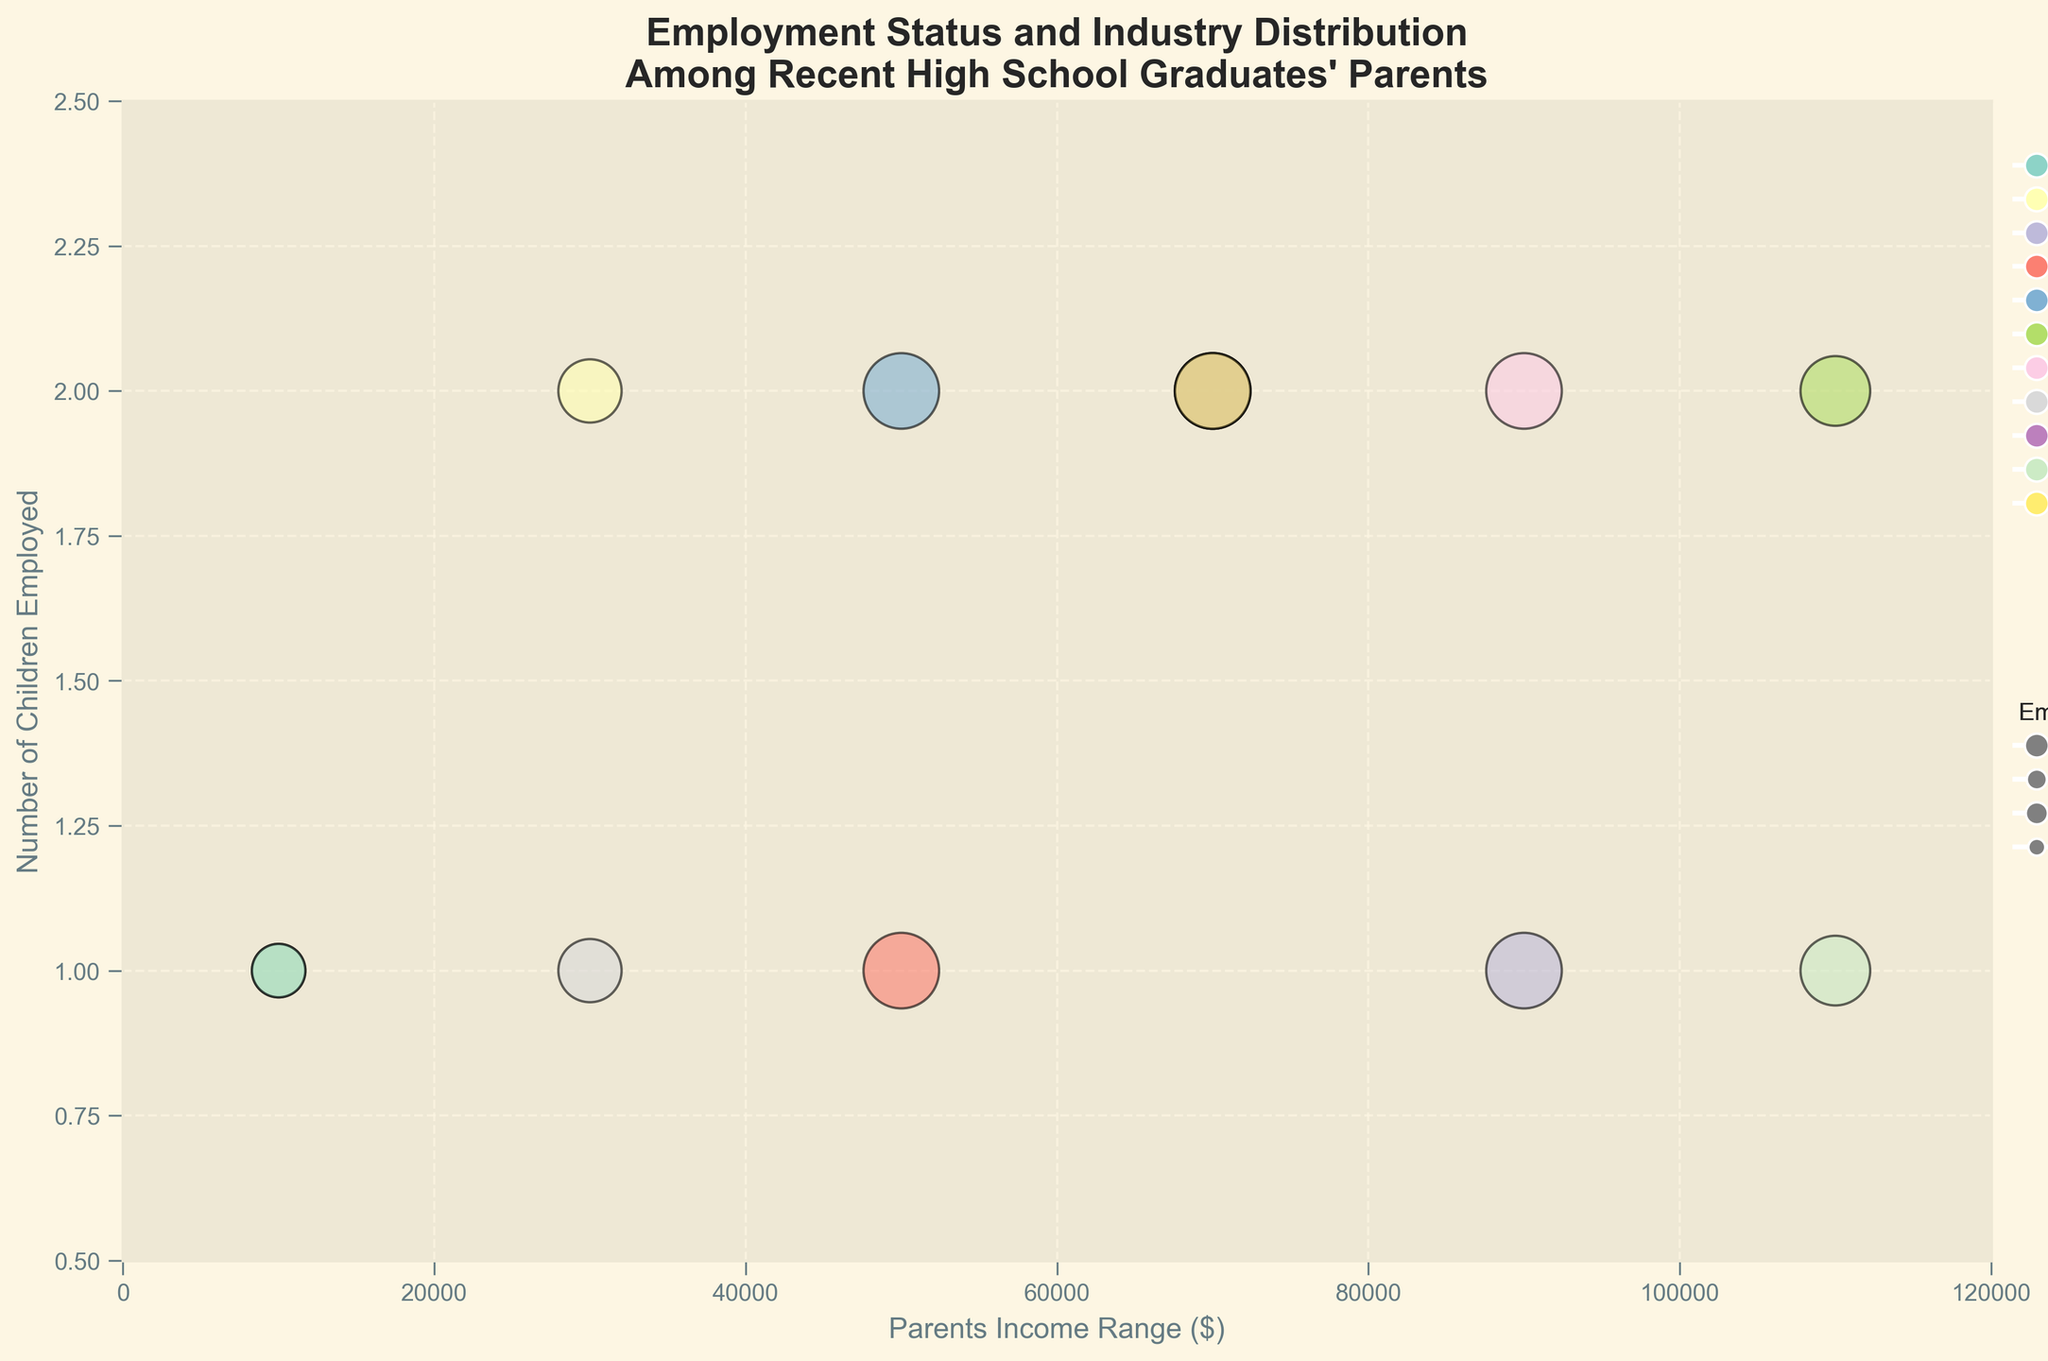What is the title of the figure? The title is usually placed at the top of the figure in a larger and bold font. In this case, it is written at the top and easy to read.
Answer: Employment Status and Industry Distribution Among Recent High School Graduates' Parents What is the range of the x-axis? The x-axis represents the Parents Income Range and spans from the minimum to the maximum value mentioned. Here, it is shown from 0 to 120000.
Answer: 0 to 120000 How many parents are from the Technology industry? Each bubble color represents a different industry. There is only one bubble colored accordingly representing Technology in the figure.
Answer: 1 Which employment status category has the largest bubbles? Employment status size categories are represented by different bubble sizes. The largest bubbles correspond to 'Employed' with a size of 100.
Answer: Employed What color is used to represent the Construction industry? Each industry is represented by a unique color. The bubble for Construction has a specific color assigned to it.
Answer: It's the color assigned to Construction (visual inspection of figure needed for accuracy) Which income range has the most parents with children employed? We look for the range along the x-axis with the most bubbles, indicating a higher density of parents in that income range. The axis ticks and bubbles imply the actual values.
Answer: 60000-80000 How many children employed correspond to parents in the 100000+ income range? By referring to the highest value on the x-axis and counting the bubble present there and its y-axis related value. There are two bubbles falling in the 100000+ income range, each linked with a different number of employed children.
Answer: 3 Do parents in the Professional Services industry have more children employed compared to those in Arts and Entertainment? Compare the y-axis value for bubbles representing these industries to determine which has more children employed.
Answer: Yes (Professional Services: 2 children, Arts and Entertainment: 1 child) Which industry other than Education has bubbles with the smallest size? Smaller sizes represent particular employment statuses. Identify the industry and correspond it to the smallest bubble size, apart from Education.
Answer: Healthcare (Part-time in Healthcare) Which industries have parents earning within the 40000-60000 range? Identify the bubbles touching the 40000-60000 range along the x-axis and look at the corresponding colors. They correspond to specific industries in the legend.
Answer: Construction, Retail 